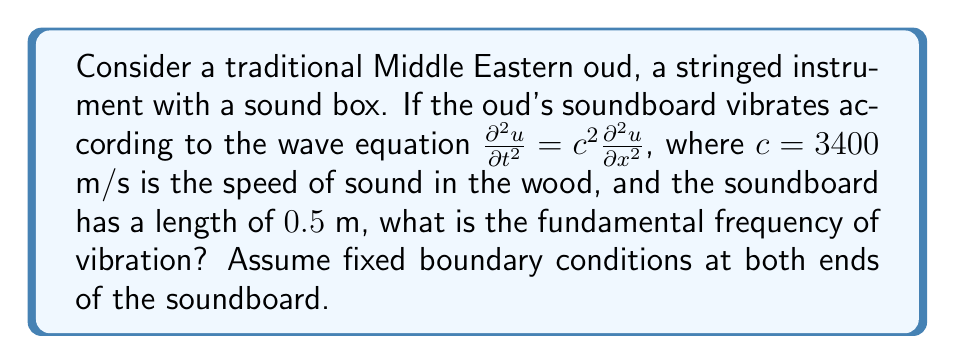Can you solve this math problem? To solve this problem, we'll follow these steps:

1) The general solution for the wave equation with fixed boundary conditions is:

   $$u(x,t) = \sum_{n=1}^{\infty} A_n \sin(\frac{n\pi x}{L}) \cos(\omega_n t)$$

   where $L$ is the length of the soundboard and $\omega_n$ are the angular frequencies.

2) The relationship between $\omega_n$ and the wave number $k_n$ is:

   $$\omega_n = ck_n$$

3) For fixed boundary conditions, the wave numbers are:

   $$k_n = \frac{n\pi}{L}$$

4) Substituting this into the dispersion relation:

   $$\omega_n = c\frac{n\pi}{L}$$

5) The fundamental frequency corresponds to $n=1$:

   $$\omega_1 = c\frac{\pi}{L}$$

6) Convert angular frequency to frequency in Hz:

   $$f_1 = \frac{\omega_1}{2\pi} = \frac{c}{2L}$$

7) Now, let's substitute the given values:

   $$f_1 = \frac{3400 \text{ m/s}}{2(0.5 \text{ m})} = 3400 \text{ Hz}$$

Thus, the fundamental frequency of vibration for the oud's soundboard is 3400 Hz.
Answer: 3400 Hz 